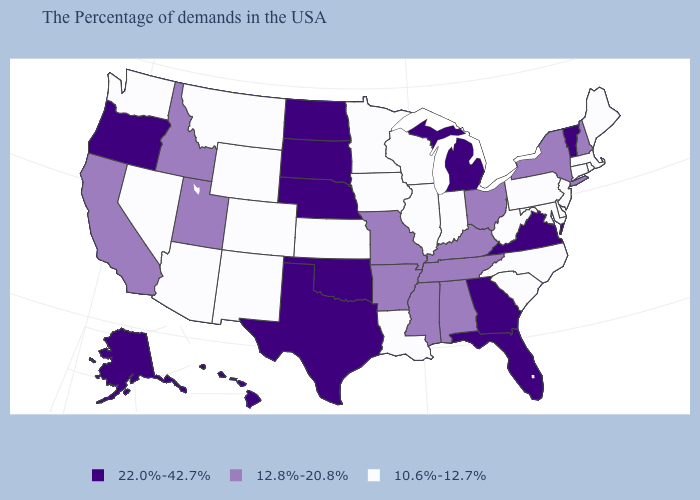What is the highest value in the USA?
Short answer required. 22.0%-42.7%. What is the value of North Dakota?
Concise answer only. 22.0%-42.7%. What is the lowest value in the USA?
Concise answer only. 10.6%-12.7%. Which states have the lowest value in the USA?
Keep it brief. Maine, Massachusetts, Rhode Island, Connecticut, New Jersey, Delaware, Maryland, Pennsylvania, North Carolina, South Carolina, West Virginia, Indiana, Wisconsin, Illinois, Louisiana, Minnesota, Iowa, Kansas, Wyoming, Colorado, New Mexico, Montana, Arizona, Nevada, Washington. Name the states that have a value in the range 10.6%-12.7%?
Be succinct. Maine, Massachusetts, Rhode Island, Connecticut, New Jersey, Delaware, Maryland, Pennsylvania, North Carolina, South Carolina, West Virginia, Indiana, Wisconsin, Illinois, Louisiana, Minnesota, Iowa, Kansas, Wyoming, Colorado, New Mexico, Montana, Arizona, Nevada, Washington. What is the value of Ohio?
Be succinct. 12.8%-20.8%. Name the states that have a value in the range 22.0%-42.7%?
Answer briefly. Vermont, Virginia, Florida, Georgia, Michigan, Nebraska, Oklahoma, Texas, South Dakota, North Dakota, Oregon, Alaska, Hawaii. Name the states that have a value in the range 10.6%-12.7%?
Answer briefly. Maine, Massachusetts, Rhode Island, Connecticut, New Jersey, Delaware, Maryland, Pennsylvania, North Carolina, South Carolina, West Virginia, Indiana, Wisconsin, Illinois, Louisiana, Minnesota, Iowa, Kansas, Wyoming, Colorado, New Mexico, Montana, Arizona, Nevada, Washington. What is the value of Vermont?
Quick response, please. 22.0%-42.7%. What is the value of Connecticut?
Quick response, please. 10.6%-12.7%. What is the lowest value in the West?
Write a very short answer. 10.6%-12.7%. Does the map have missing data?
Concise answer only. No. What is the value of Nevada?
Write a very short answer. 10.6%-12.7%. What is the lowest value in the West?
Answer briefly. 10.6%-12.7%. What is the lowest value in states that border Indiana?
Be succinct. 10.6%-12.7%. 